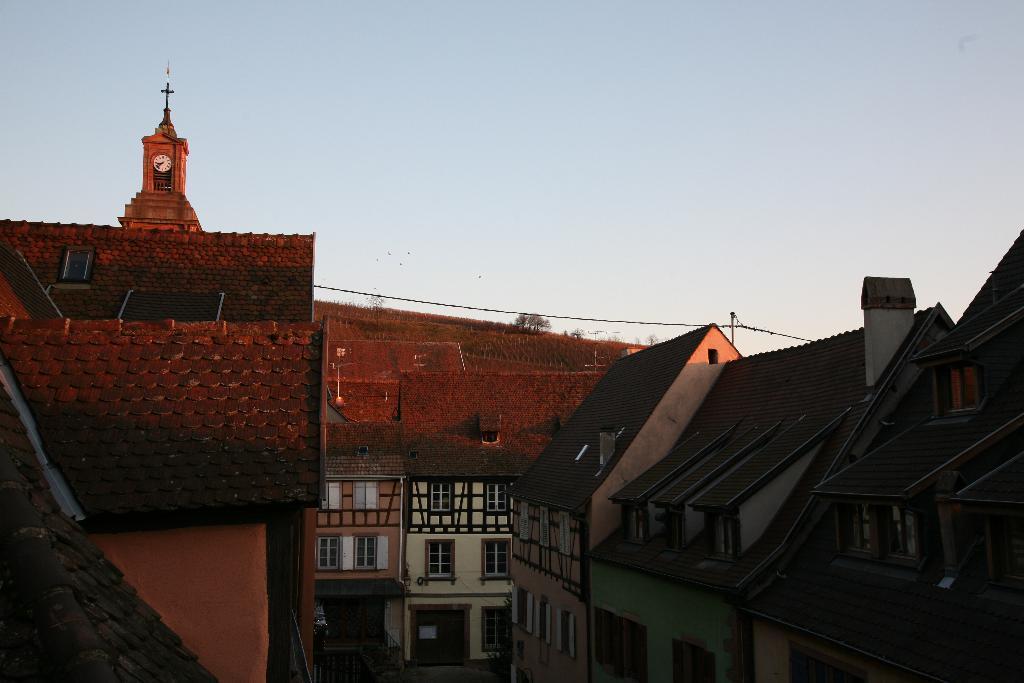In one or two sentences, can you explain what this image depicts? In this image we can see some buildings and on the top left corner of the image there is a clock. 